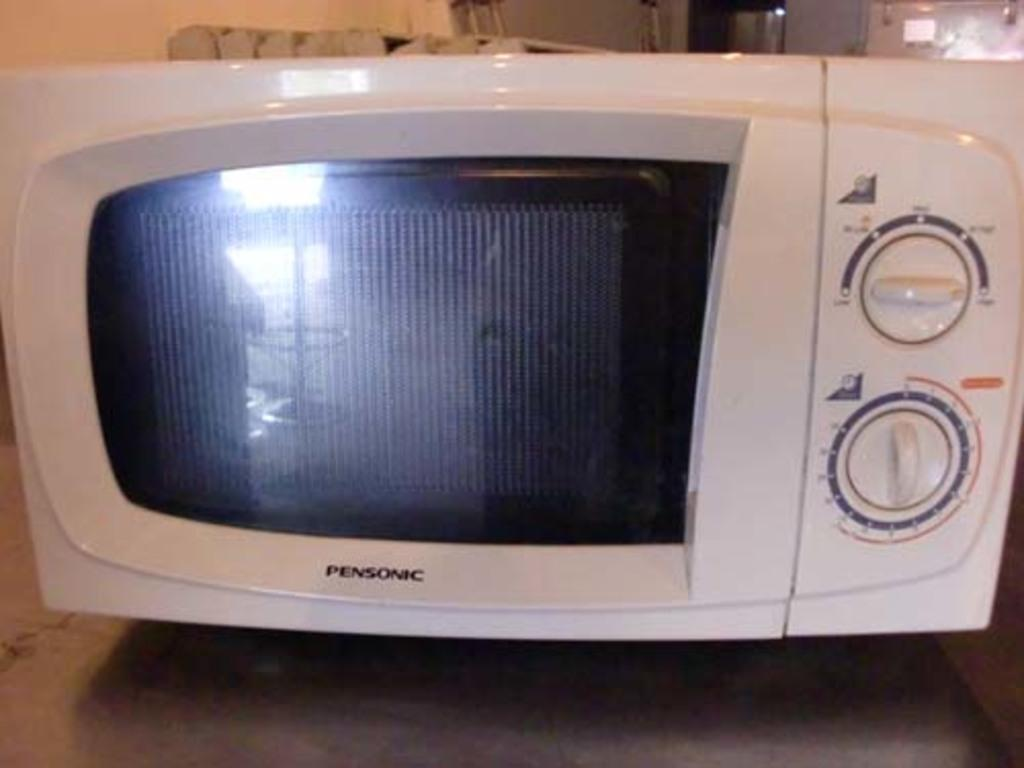<image>
Relay a brief, clear account of the picture shown. A white pensonic microwave with two dials on the right side. 